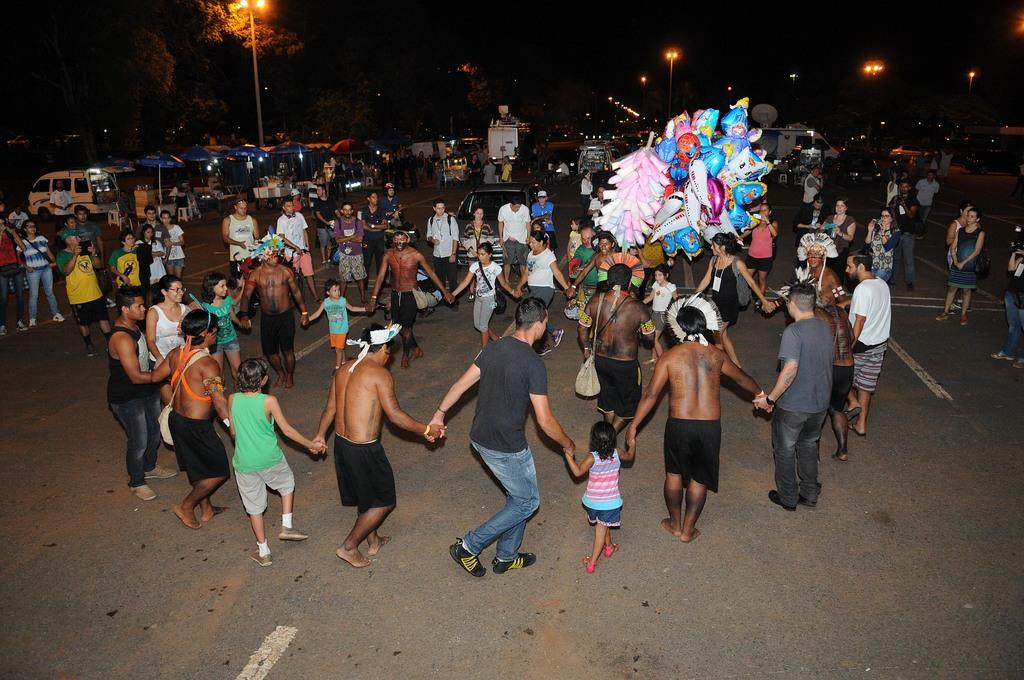What are the people in the image doing? The people in the image are standing in a circle on the road. What else can be seen in the image besides the people? Toys, umbrellas, vehicles, light poles, trees, and the dark sky are visible in the image. What type of stone is being used to make the pot in the image? There is no pot or stone present in the image. What kind of apparel are the people wearing in the image? The provided facts do not mention the apparel worn by the people in the image. 